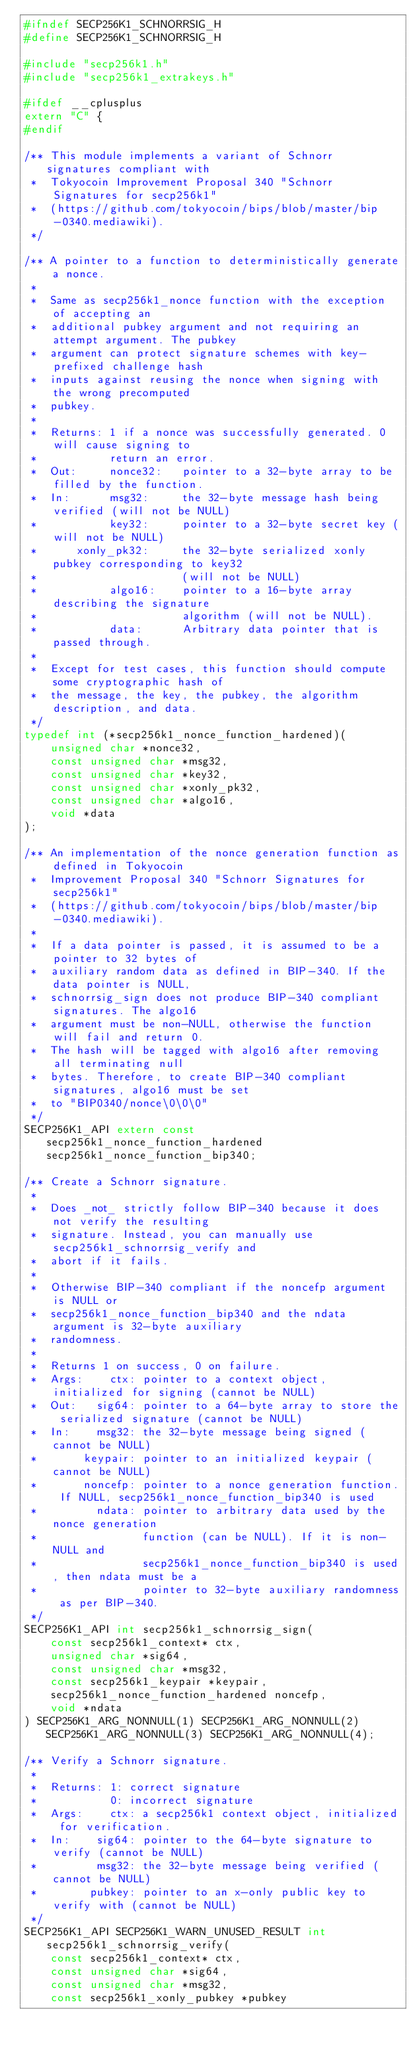<code> <loc_0><loc_0><loc_500><loc_500><_C_>#ifndef SECP256K1_SCHNORRSIG_H
#define SECP256K1_SCHNORRSIG_H

#include "secp256k1.h"
#include "secp256k1_extrakeys.h"

#ifdef __cplusplus
extern "C" {
#endif

/** This module implements a variant of Schnorr signatures compliant with
 *  Tokyocoin Improvement Proposal 340 "Schnorr Signatures for secp256k1"
 *  (https://github.com/tokyocoin/bips/blob/master/bip-0340.mediawiki).
 */

/** A pointer to a function to deterministically generate a nonce.
 *
 *  Same as secp256k1_nonce function with the exception of accepting an
 *  additional pubkey argument and not requiring an attempt argument. The pubkey
 *  argument can protect signature schemes with key-prefixed challenge hash
 *  inputs against reusing the nonce when signing with the wrong precomputed
 *  pubkey.
 *
 *  Returns: 1 if a nonce was successfully generated. 0 will cause signing to
 *           return an error.
 *  Out:     nonce32:   pointer to a 32-byte array to be filled by the function.
 *  In:      msg32:     the 32-byte message hash being verified (will not be NULL)
 *           key32:     pointer to a 32-byte secret key (will not be NULL)
 *      xonly_pk32:     the 32-byte serialized xonly pubkey corresponding to key32
 *                      (will not be NULL)
 *           algo16:    pointer to a 16-byte array describing the signature
 *                      algorithm (will not be NULL).
 *           data:      Arbitrary data pointer that is passed through.
 *
 *  Except for test cases, this function should compute some cryptographic hash of
 *  the message, the key, the pubkey, the algorithm description, and data.
 */
typedef int (*secp256k1_nonce_function_hardened)(
    unsigned char *nonce32,
    const unsigned char *msg32,
    const unsigned char *key32,
    const unsigned char *xonly_pk32,
    const unsigned char *algo16,
    void *data
);

/** An implementation of the nonce generation function as defined in Tokyocoin
 *  Improvement Proposal 340 "Schnorr Signatures for secp256k1"
 *  (https://github.com/tokyocoin/bips/blob/master/bip-0340.mediawiki).
 *
 *  If a data pointer is passed, it is assumed to be a pointer to 32 bytes of
 *  auxiliary random data as defined in BIP-340. If the data pointer is NULL,
 *  schnorrsig_sign does not produce BIP-340 compliant signatures. The algo16
 *  argument must be non-NULL, otherwise the function will fail and return 0.
 *  The hash will be tagged with algo16 after removing all terminating null
 *  bytes. Therefore, to create BIP-340 compliant signatures, algo16 must be set
 *  to "BIP0340/nonce\0\0\0"
 */
SECP256K1_API extern const secp256k1_nonce_function_hardened secp256k1_nonce_function_bip340;

/** Create a Schnorr signature.
 *
 *  Does _not_ strictly follow BIP-340 because it does not verify the resulting
 *  signature. Instead, you can manually use secp256k1_schnorrsig_verify and
 *  abort if it fails.
 *
 *  Otherwise BIP-340 compliant if the noncefp argument is NULL or
 *  secp256k1_nonce_function_bip340 and the ndata argument is 32-byte auxiliary
 *  randomness.
 *
 *  Returns 1 on success, 0 on failure.
 *  Args:    ctx: pointer to a context object, initialized for signing (cannot be NULL)
 *  Out:   sig64: pointer to a 64-byte array to store the serialized signature (cannot be NULL)
 *  In:    msg32: the 32-byte message being signed (cannot be NULL)
 *       keypair: pointer to an initialized keypair (cannot be NULL)
 *       noncefp: pointer to a nonce generation function. If NULL, secp256k1_nonce_function_bip340 is used
 *         ndata: pointer to arbitrary data used by the nonce generation
 *                function (can be NULL). If it is non-NULL and
 *                secp256k1_nonce_function_bip340 is used, then ndata must be a
 *                pointer to 32-byte auxiliary randomness as per BIP-340.
 */
SECP256K1_API int secp256k1_schnorrsig_sign(
    const secp256k1_context* ctx,
    unsigned char *sig64,
    const unsigned char *msg32,
    const secp256k1_keypair *keypair,
    secp256k1_nonce_function_hardened noncefp,
    void *ndata
) SECP256K1_ARG_NONNULL(1) SECP256K1_ARG_NONNULL(2) SECP256K1_ARG_NONNULL(3) SECP256K1_ARG_NONNULL(4);

/** Verify a Schnorr signature.
 *
 *  Returns: 1: correct signature
 *           0: incorrect signature
 *  Args:    ctx: a secp256k1 context object, initialized for verification.
 *  In:    sig64: pointer to the 64-byte signature to verify (cannot be NULL)
 *         msg32: the 32-byte message being verified (cannot be NULL)
 *        pubkey: pointer to an x-only public key to verify with (cannot be NULL)
 */
SECP256K1_API SECP256K1_WARN_UNUSED_RESULT int secp256k1_schnorrsig_verify(
    const secp256k1_context* ctx,
    const unsigned char *sig64,
    const unsigned char *msg32,
    const secp256k1_xonly_pubkey *pubkey</code> 